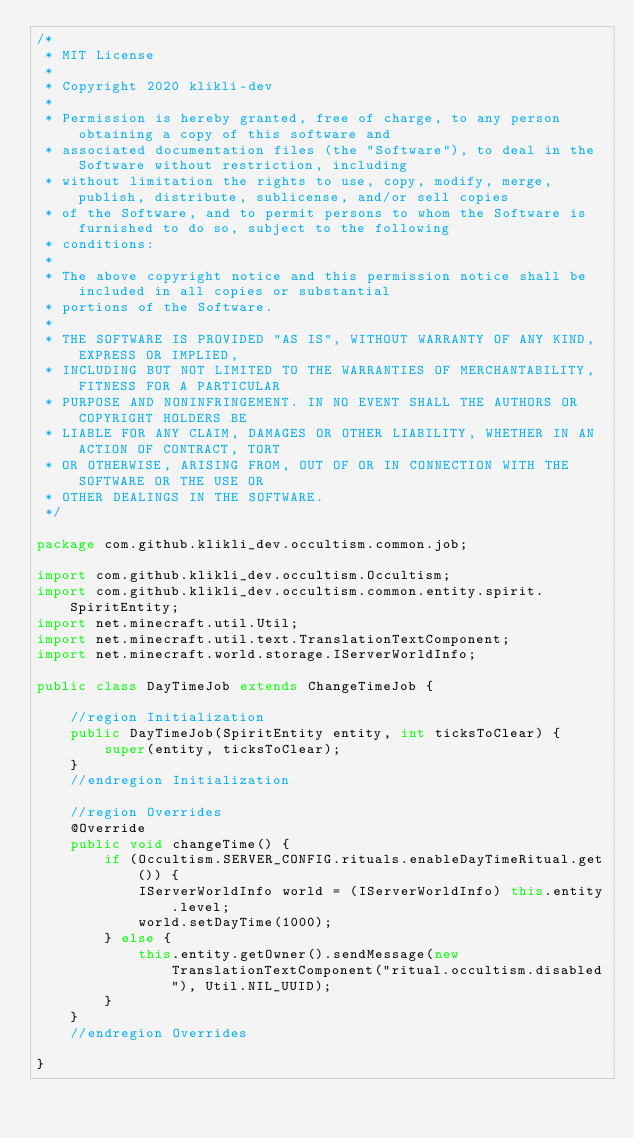<code> <loc_0><loc_0><loc_500><loc_500><_Java_>/*
 * MIT License
 *
 * Copyright 2020 klikli-dev
 *
 * Permission is hereby granted, free of charge, to any person obtaining a copy of this software and
 * associated documentation files (the "Software"), to deal in the Software without restriction, including
 * without limitation the rights to use, copy, modify, merge, publish, distribute, sublicense, and/or sell copies
 * of the Software, and to permit persons to whom the Software is furnished to do so, subject to the following
 * conditions:
 *
 * The above copyright notice and this permission notice shall be included in all copies or substantial
 * portions of the Software.
 *
 * THE SOFTWARE IS PROVIDED "AS IS", WITHOUT WARRANTY OF ANY KIND, EXPRESS OR IMPLIED,
 * INCLUDING BUT NOT LIMITED TO THE WARRANTIES OF MERCHANTABILITY, FITNESS FOR A PARTICULAR
 * PURPOSE AND NONINFRINGEMENT. IN NO EVENT SHALL THE AUTHORS OR COPYRIGHT HOLDERS BE
 * LIABLE FOR ANY CLAIM, DAMAGES OR OTHER LIABILITY, WHETHER IN AN ACTION OF CONTRACT, TORT
 * OR OTHERWISE, ARISING FROM, OUT OF OR IN CONNECTION WITH THE SOFTWARE OR THE USE OR
 * OTHER DEALINGS IN THE SOFTWARE.
 */

package com.github.klikli_dev.occultism.common.job;

import com.github.klikli_dev.occultism.Occultism;
import com.github.klikli_dev.occultism.common.entity.spirit.SpiritEntity;
import net.minecraft.util.Util;
import net.minecraft.util.text.TranslationTextComponent;
import net.minecraft.world.storage.IServerWorldInfo;

public class DayTimeJob extends ChangeTimeJob {

    //region Initialization
    public DayTimeJob(SpiritEntity entity, int ticksToClear) {
        super(entity, ticksToClear);
    }
    //endregion Initialization

    //region Overrides
    @Override
    public void changeTime() {
        if (Occultism.SERVER_CONFIG.rituals.enableDayTimeRitual.get()) {
            IServerWorldInfo world = (IServerWorldInfo) this.entity.level;
            world.setDayTime(1000);
        } else {
            this.entity.getOwner().sendMessage(new TranslationTextComponent("ritual.occultism.disabled"), Util.NIL_UUID);
        }
    }
    //endregion Overrides

}
</code> 